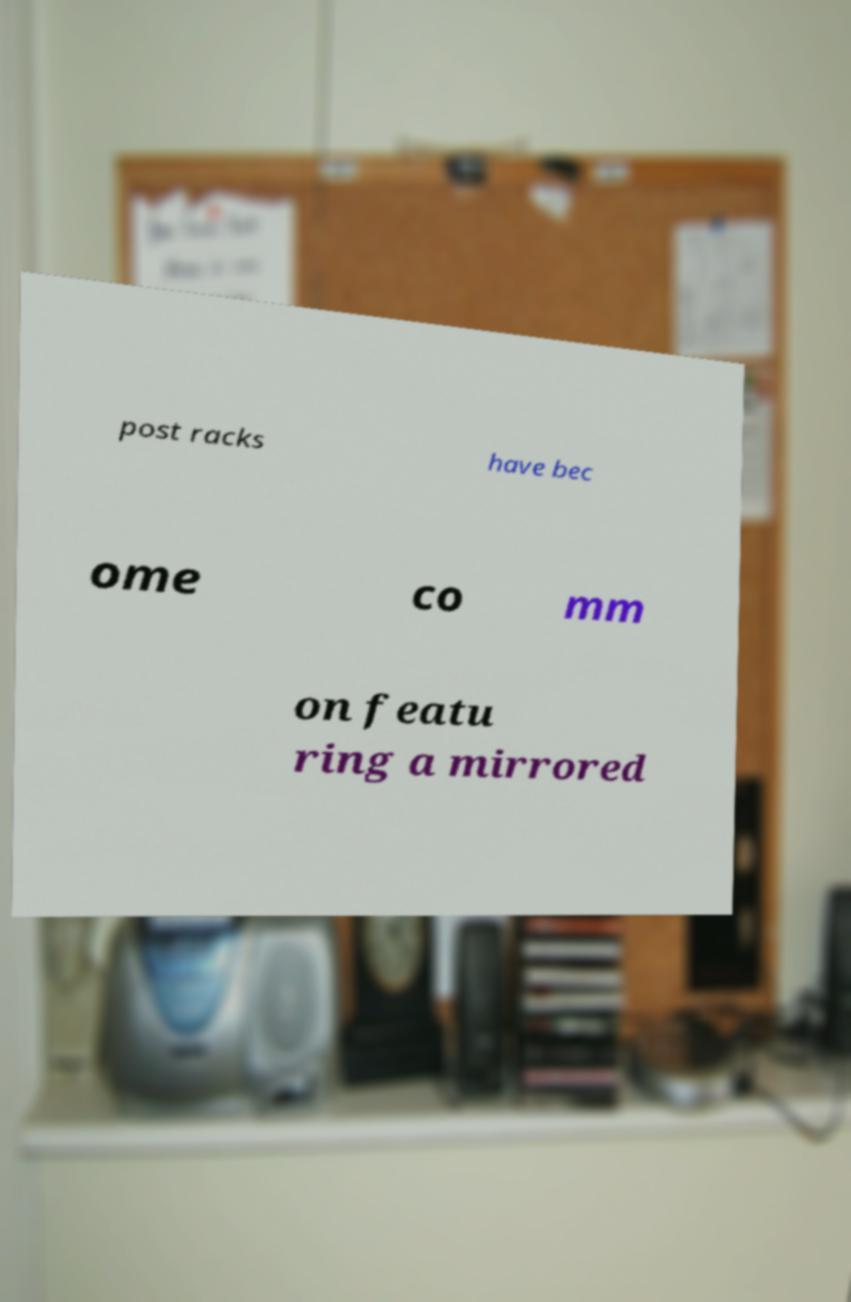Please identify and transcribe the text found in this image. post racks have bec ome co mm on featu ring a mirrored 